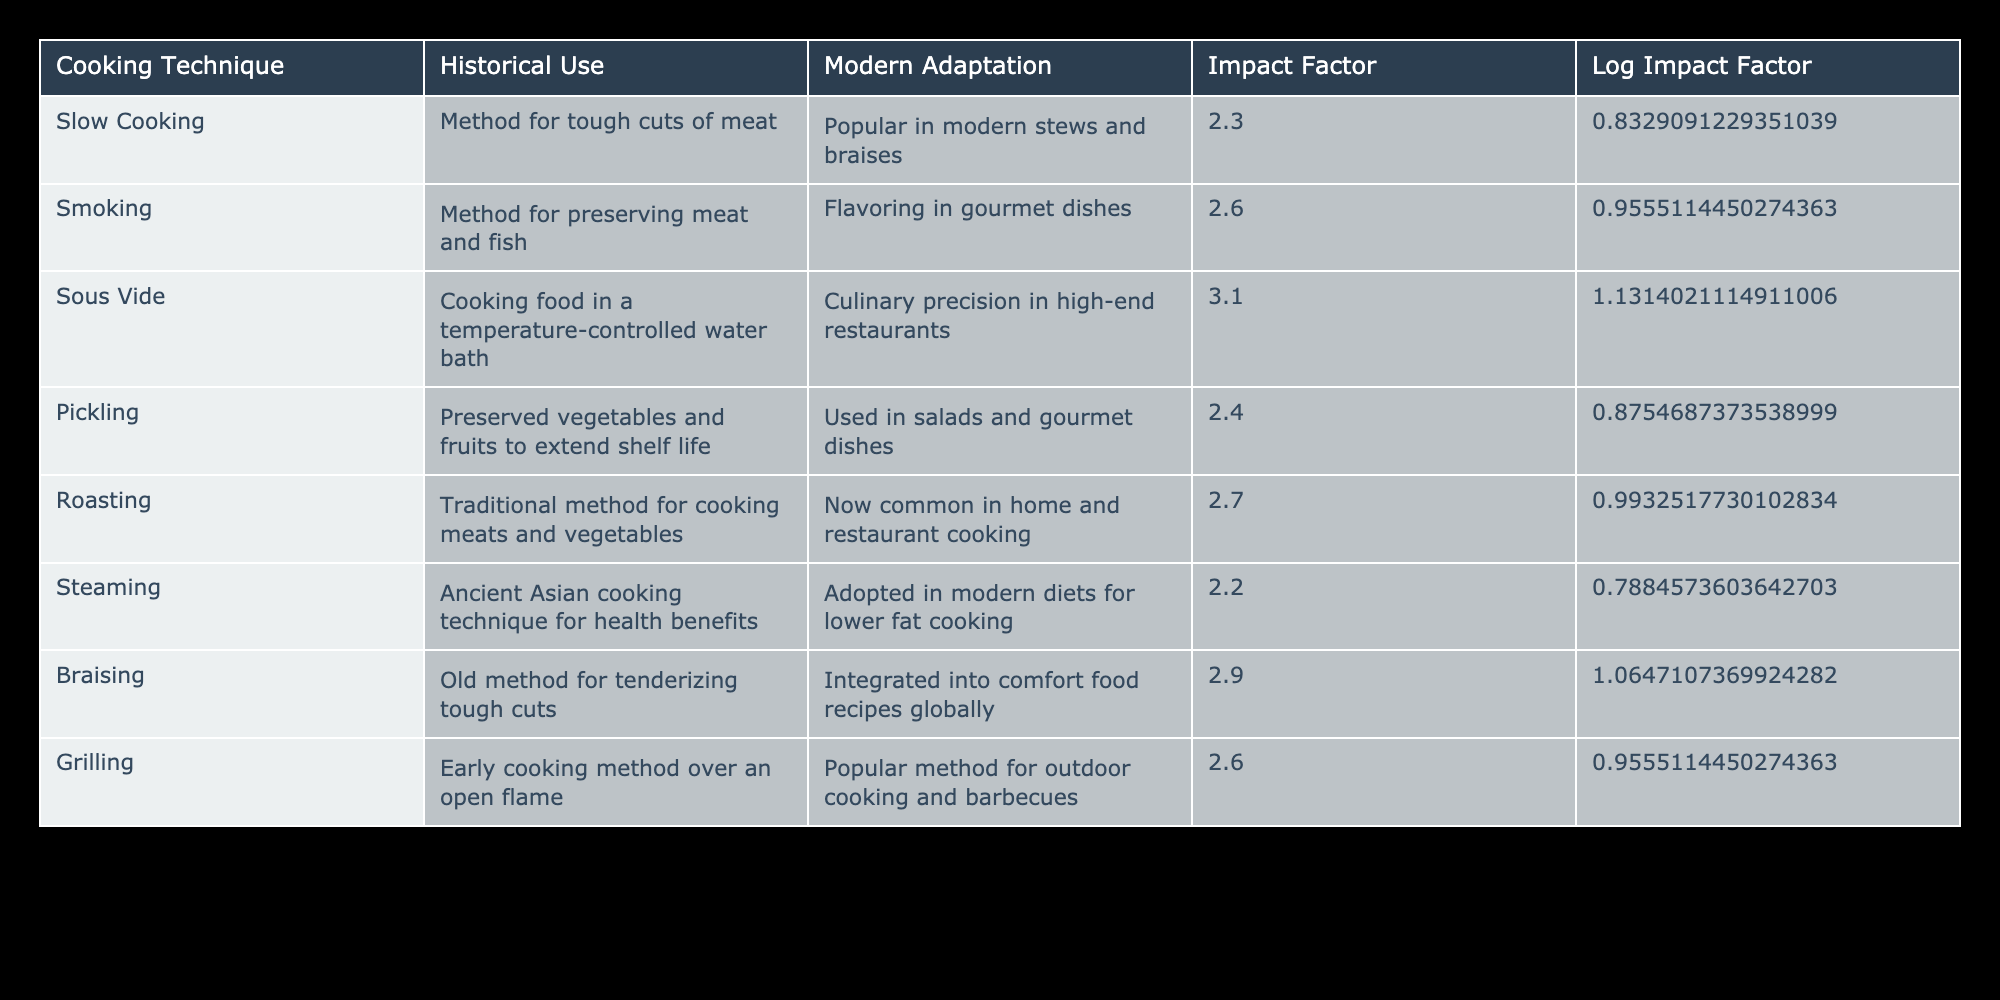What is the modern adaptation for smoking? The table states that smoking's modern adaptation is as a flavoring in gourmet dishes.
Answer: Flavoring in gourmet dishes Which cooking technique has the highest impact factor? By reviewing the impact factors listed, sous vide has the highest value at 3.1.
Answer: 3.1 Is braising integrated into comfort food recipes globally? The table indicates that braising is indeed integrated into comfort food recipes globally, making this statement true.
Answer: Yes What is the average impact factor of slow cooking and steaming? First, locate the impact factors: slow cooking is 2.3, and steaming is 2.2. Then, calculate their average: (2.3 + 2.2) / 2 = 2.25.
Answer: 2.25 Does pickling have a higher modern adaptation value than roasting? The table does not assign values for modern adaptations; it simply states uses. Therefore, it's invalid to compare them based on this criterion.
Answer: No 